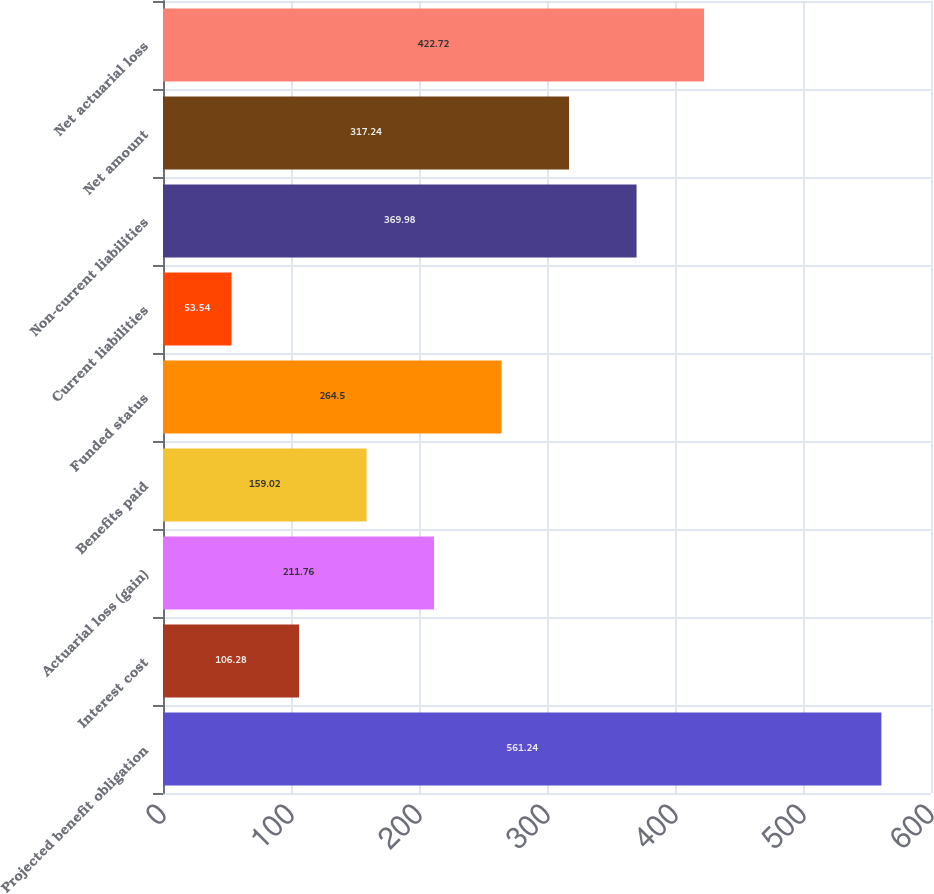Convert chart to OTSL. <chart><loc_0><loc_0><loc_500><loc_500><bar_chart><fcel>Projected benefit obligation<fcel>Interest cost<fcel>Actuarial loss (gain)<fcel>Benefits paid<fcel>Funded status<fcel>Current liabilities<fcel>Non-current liabilities<fcel>Net amount<fcel>Net actuarial loss<nl><fcel>561.24<fcel>106.28<fcel>211.76<fcel>159.02<fcel>264.5<fcel>53.54<fcel>369.98<fcel>317.24<fcel>422.72<nl></chart> 